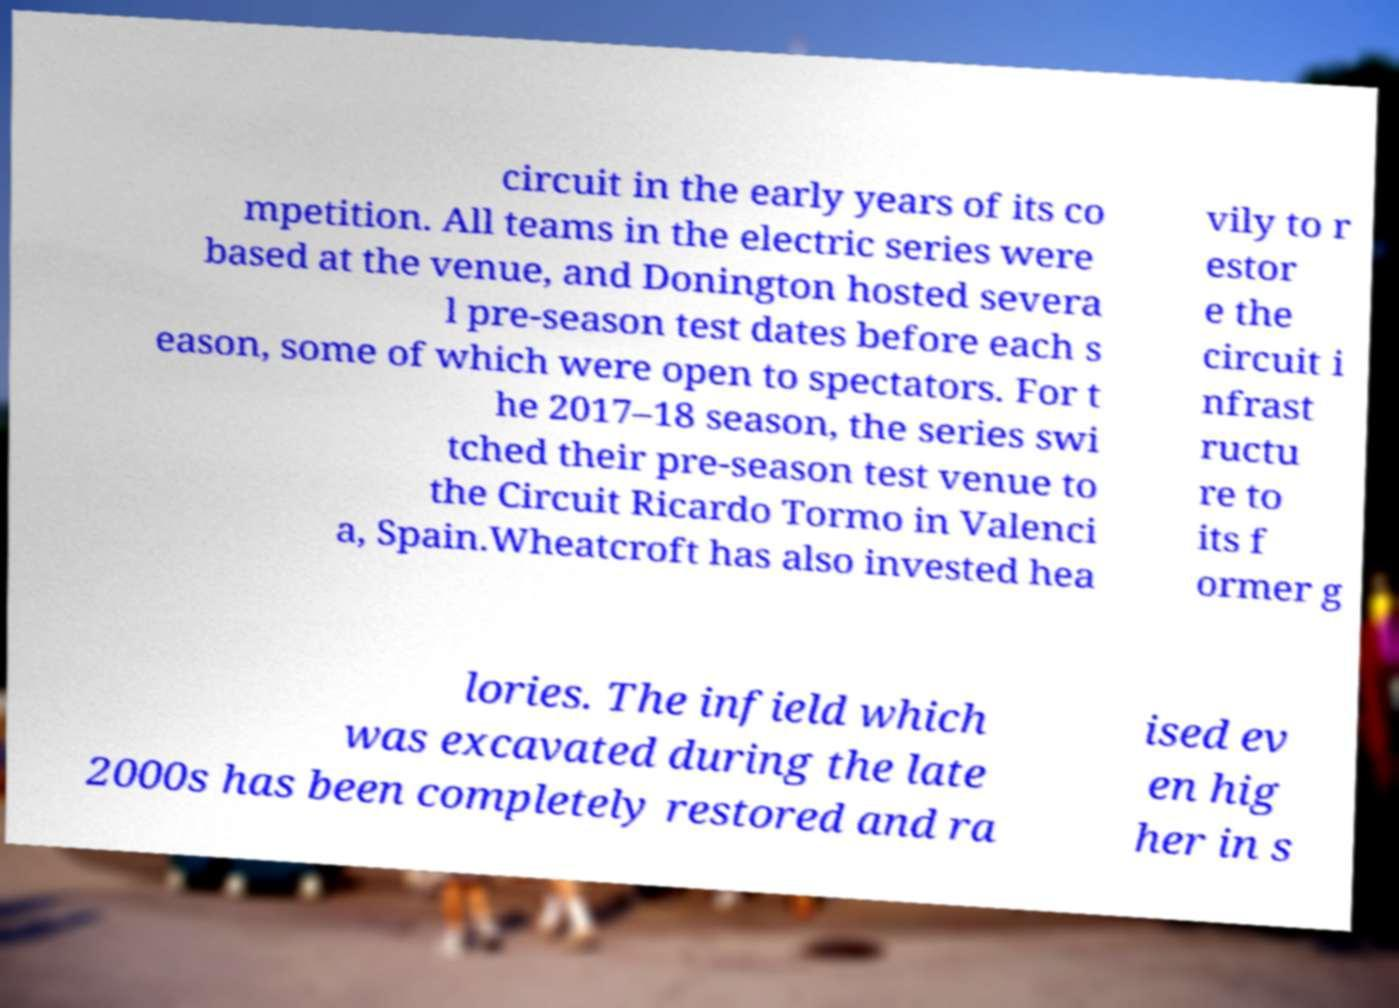There's text embedded in this image that I need extracted. Can you transcribe it verbatim? circuit in the early years of its co mpetition. All teams in the electric series were based at the venue, and Donington hosted severa l pre-season test dates before each s eason, some of which were open to spectators. For t he 2017–18 season, the series swi tched their pre-season test venue to the Circuit Ricardo Tormo in Valenci a, Spain.Wheatcroft has also invested hea vily to r estor e the circuit i nfrast ructu re to its f ormer g lories. The infield which was excavated during the late 2000s has been completely restored and ra ised ev en hig her in s 